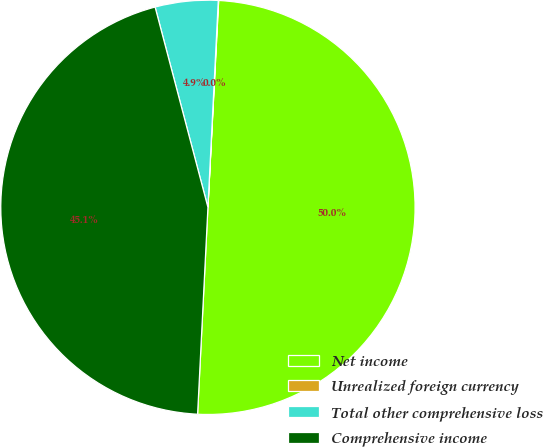Convert chart. <chart><loc_0><loc_0><loc_500><loc_500><pie_chart><fcel>Net income<fcel>Unrealized foreign currency<fcel>Total other comprehensive loss<fcel>Comprehensive income<nl><fcel>49.97%<fcel>0.03%<fcel>4.9%<fcel>45.1%<nl></chart> 